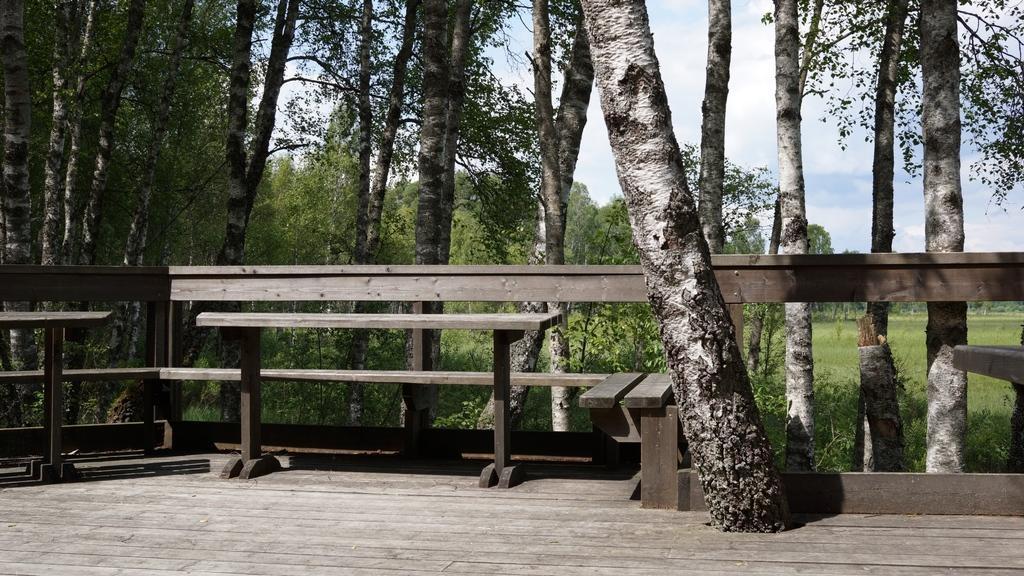Could you give a brief overview of what you see in this image? In this image we can see a wooden fencing and wooden bench. Behind it so many trees are present and the land is full of grass. The sky is blue with some clouds. 